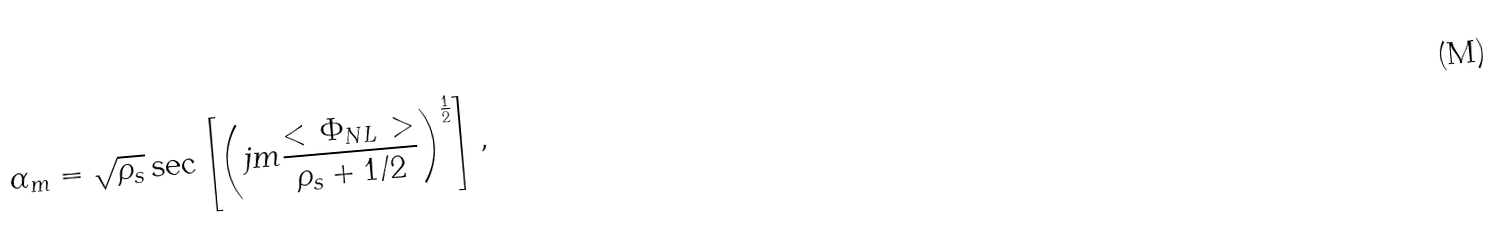Convert formula to latex. <formula><loc_0><loc_0><loc_500><loc_500>\alpha _ { m } = \sqrt { \rho _ { s } } \sec \left [ \left ( j m \frac { < \, \Phi _ { N L } \, > } { \rho _ { s } + 1 / 2 } \right ) ^ { \frac { 1 } { 2 } } \right ] ,</formula> 